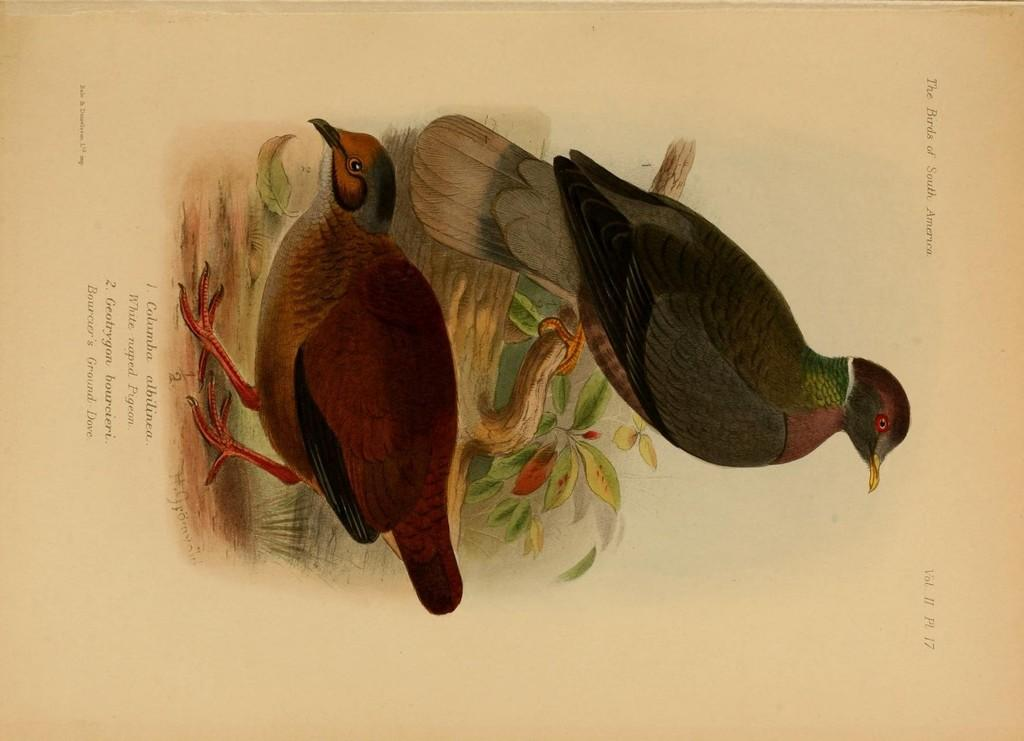What is depicted on the paper in the image? The paper contains an art of two birds. What else can be found on the paper besides the art? There is text on the paper. What type of noise can be heard coming from the toy in the image? There is no toy present in the image, so it's not possible to determine what noise might be heard. 